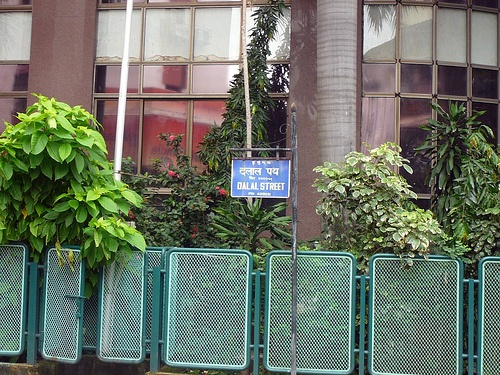Describe the objects in this image and their specific colors. I can see various objects in this image with different colors. 